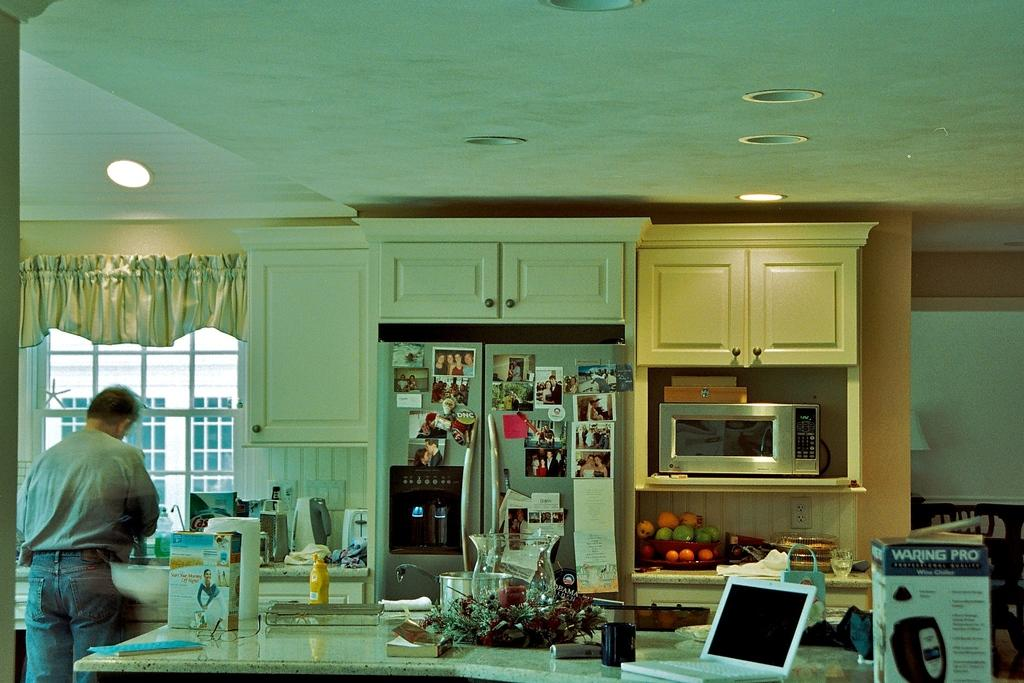<image>
Create a compact narrative representing the image presented. a kitchen with a box on the counter that is labeled as 'waring pro' 